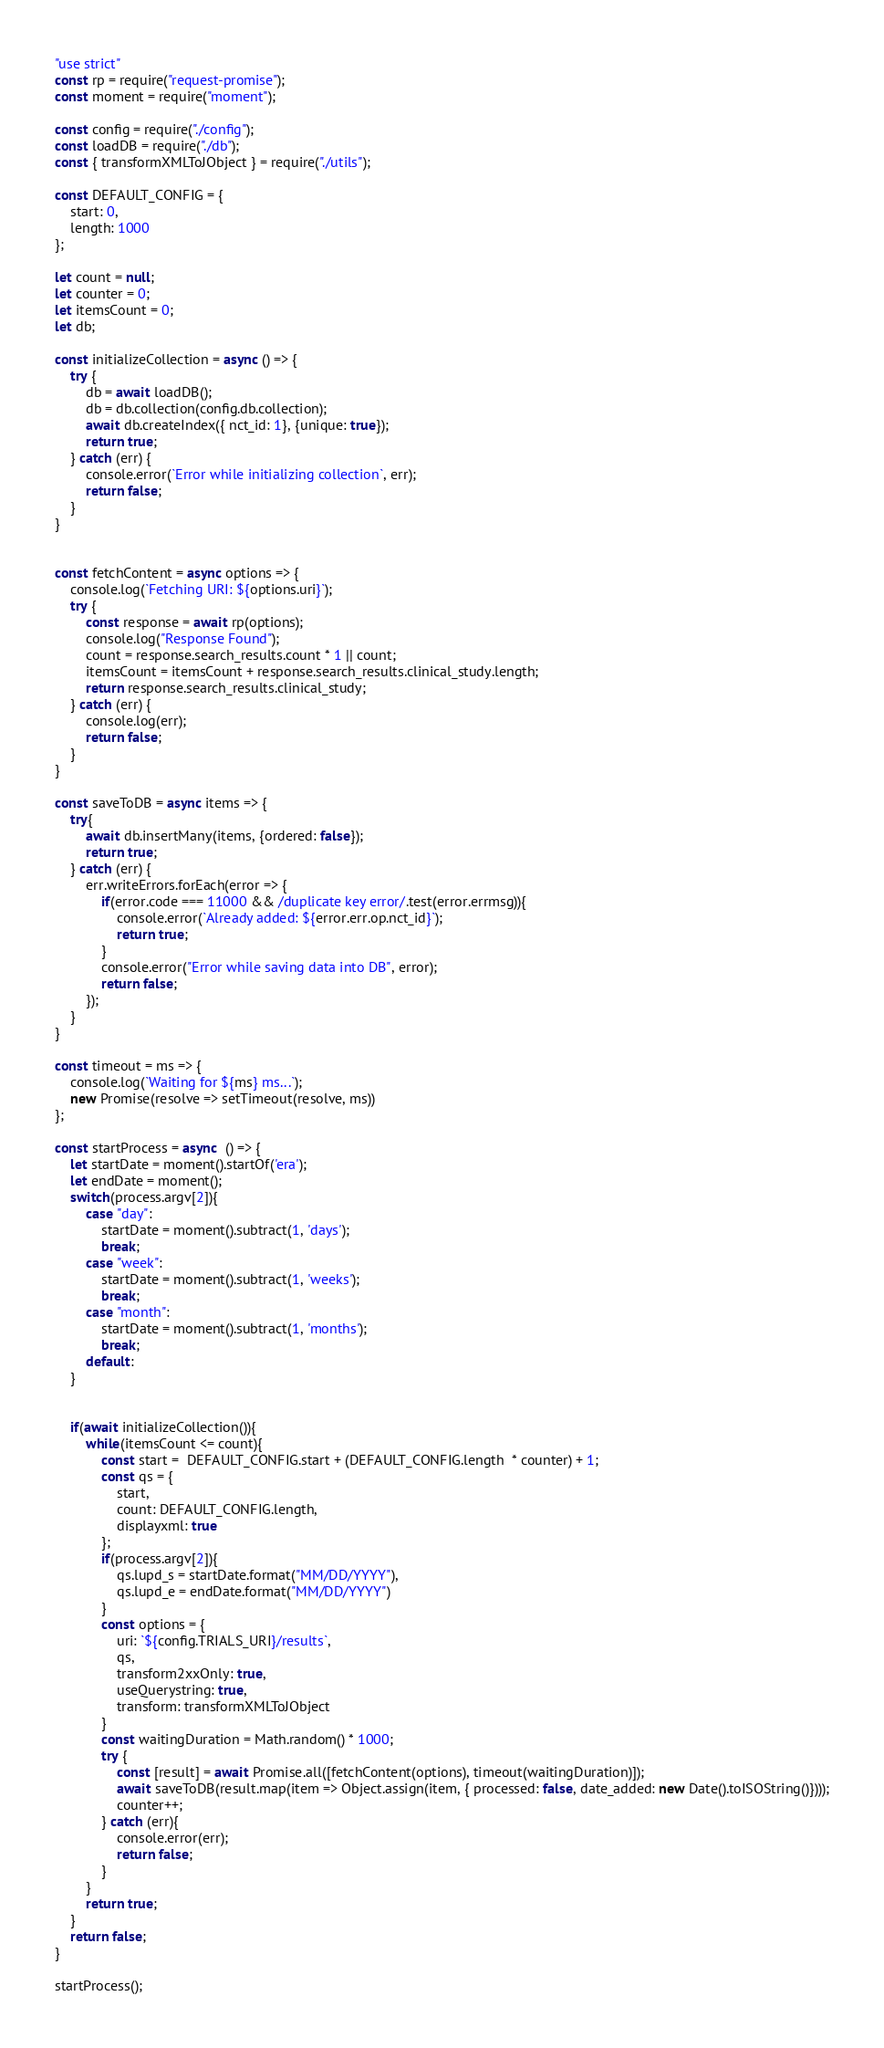Convert code to text. <code><loc_0><loc_0><loc_500><loc_500><_JavaScript_>"use strict"
const rp = require("request-promise");
const moment = require("moment");

const config = require("./config");
const loadDB = require("./db");
const { transformXMLToJObject } = require("./utils");

const DEFAULT_CONFIG = {
    start: 0,
    length: 1000
};

let count = null;
let counter = 0;
let itemsCount = 0;
let db;

const initializeCollection = async () => {
    try {
        db = await loadDB();
        db = db.collection(config.db.collection);
        await db.createIndex({ nct_id: 1}, {unique: true});
        return true;
    } catch (err) {
        console.error(`Error while initializing collection`, err);
        return false;
    }       
}


const fetchContent = async options => {
    console.log(`Fetching URI: ${options.uri}`);
    try {
        const response = await rp(options);
        console.log("Response Found");
        count = response.search_results.count * 1 || count;
        itemsCount = itemsCount + response.search_results.clinical_study.length;
        return response.search_results.clinical_study;
    } catch (err) {
        console.log(err);
        return false;
    }
}

const saveToDB = async items => {
    try{
        await db.insertMany(items, {ordered: false});
        return true;
    } catch (err) {
        err.writeErrors.forEach(error => {
            if(error.code === 11000 && /duplicate key error/.test(error.errmsg)){
                console.error(`Already added: ${error.err.op.nct_id}`);
                return true;
            }
            console.error("Error while saving data into DB", error);
            return false;
        });
    }
}

const timeout = ms => {
    console.log(`Waiting for ${ms} ms...`);
    new Promise(resolve => setTimeout(resolve, ms))
};

const startProcess = async  () => {
    let startDate = moment().startOf('era');
    let endDate = moment();
    switch(process.argv[2]){
        case "day": 
            startDate = moment().subtract(1, 'days');
            break;
        case "week": 
            startDate = moment().subtract(1, 'weeks');
            break;
        case "month": 
            startDate = moment().subtract(1, 'months');
            break;
        default:
    }


    if(await initializeCollection()){
        while(itemsCount <= count){
            const start =  DEFAULT_CONFIG.start + (DEFAULT_CONFIG.length  * counter) + 1;
            const qs = {
                start,
                count: DEFAULT_CONFIG.length,
                displayxml: true
            };
            if(process.argv[2]){
                qs.lupd_s = startDate.format("MM/DD/YYYY"),
                qs.lupd_e = endDate.format("MM/DD/YYYY")
            }
            const options = {
                uri: `${config.TRIALS_URI}/results`,
                qs,
                transform2xxOnly: true,
                useQuerystring: true,
                transform: transformXMLToJObject
            }
            const waitingDuration = Math.random() * 1000;
            try {
                const [result] = await Promise.all([fetchContent(options), timeout(waitingDuration)]);
                await saveToDB(result.map(item => Object.assign(item, { processed: false, date_added: new Date().toISOString()})));
                counter++;
            } catch (err){
                console.error(err);
                return false;
            }
        }
        return true;
    }
    return false;
}

startProcess();</code> 